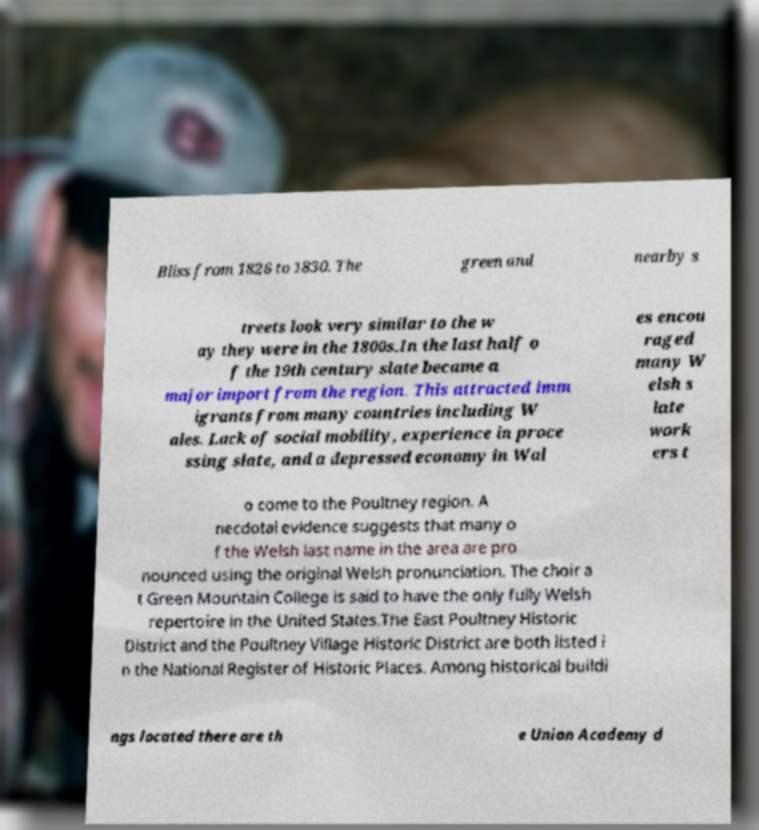I need the written content from this picture converted into text. Can you do that? Bliss from 1826 to 1830. The green and nearby s treets look very similar to the w ay they were in the 1800s.In the last half o f the 19th century slate became a major import from the region. This attracted imm igrants from many countries including W ales. Lack of social mobility, experience in proce ssing slate, and a depressed economy in Wal es encou raged many W elsh s late work ers t o come to the Poultney region. A necdotal evidence suggests that many o f the Welsh last name in the area are pro nounced using the original Welsh pronunciation. The choir a t Green Mountain College is said to have the only fully Welsh repertoire in the United States.The East Poultney Historic District and the Poultney Village Historic District are both listed i n the National Register of Historic Places. Among historical buildi ngs located there are th e Union Academy d 